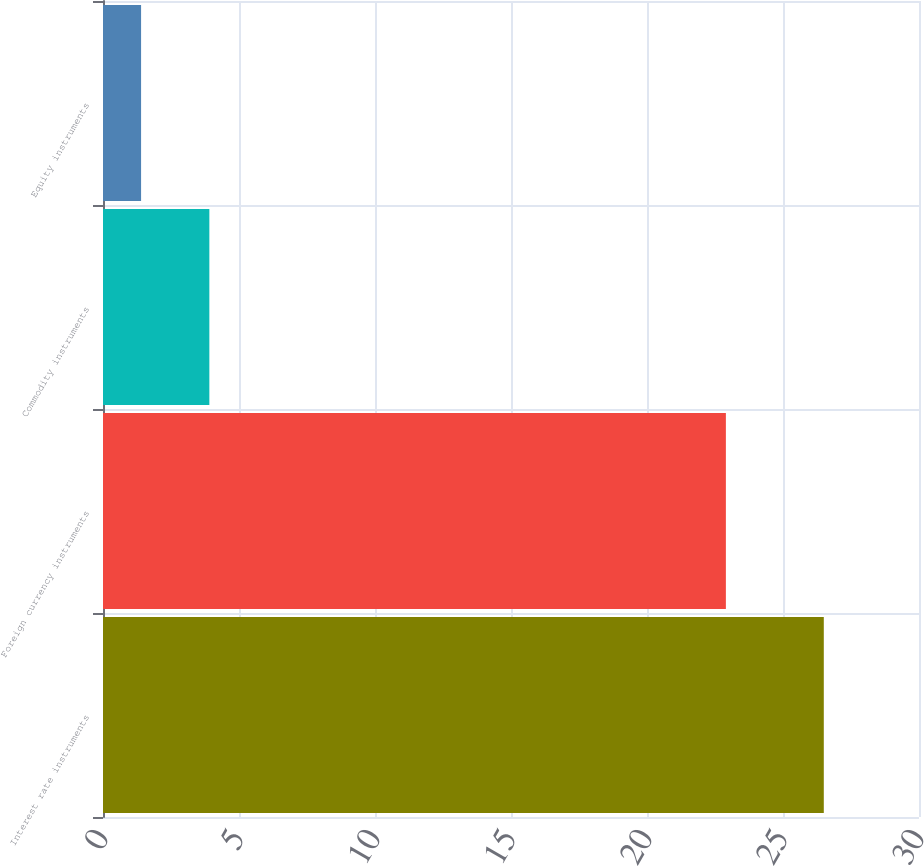Convert chart to OTSL. <chart><loc_0><loc_0><loc_500><loc_500><bar_chart><fcel>Interest rate instruments<fcel>Foreign currency instruments<fcel>Commodity instruments<fcel>Equity instruments<nl><fcel>26.5<fcel>22.9<fcel>3.91<fcel>1.4<nl></chart> 